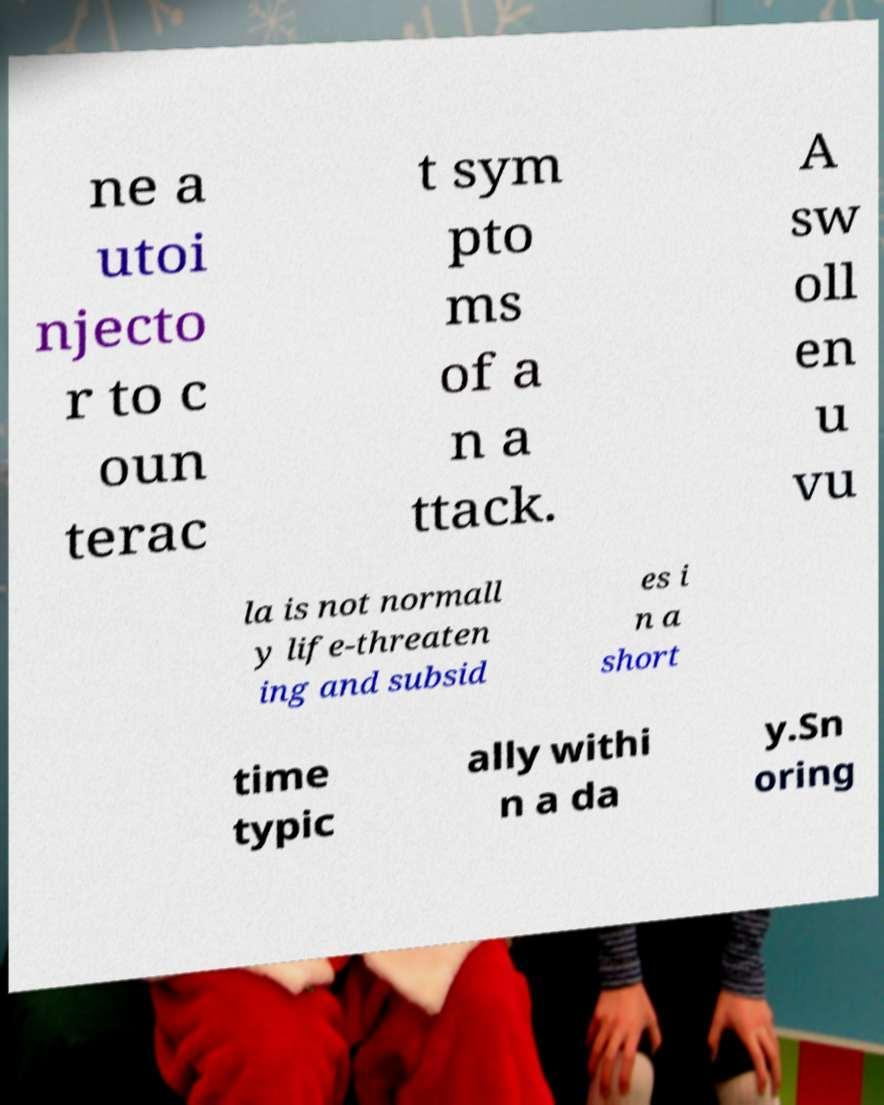There's text embedded in this image that I need extracted. Can you transcribe it verbatim? ne a utoi njecto r to c oun terac t sym pto ms of a n a ttack. A sw oll en u vu la is not normall y life-threaten ing and subsid es i n a short time typic ally withi n a da y.Sn oring 